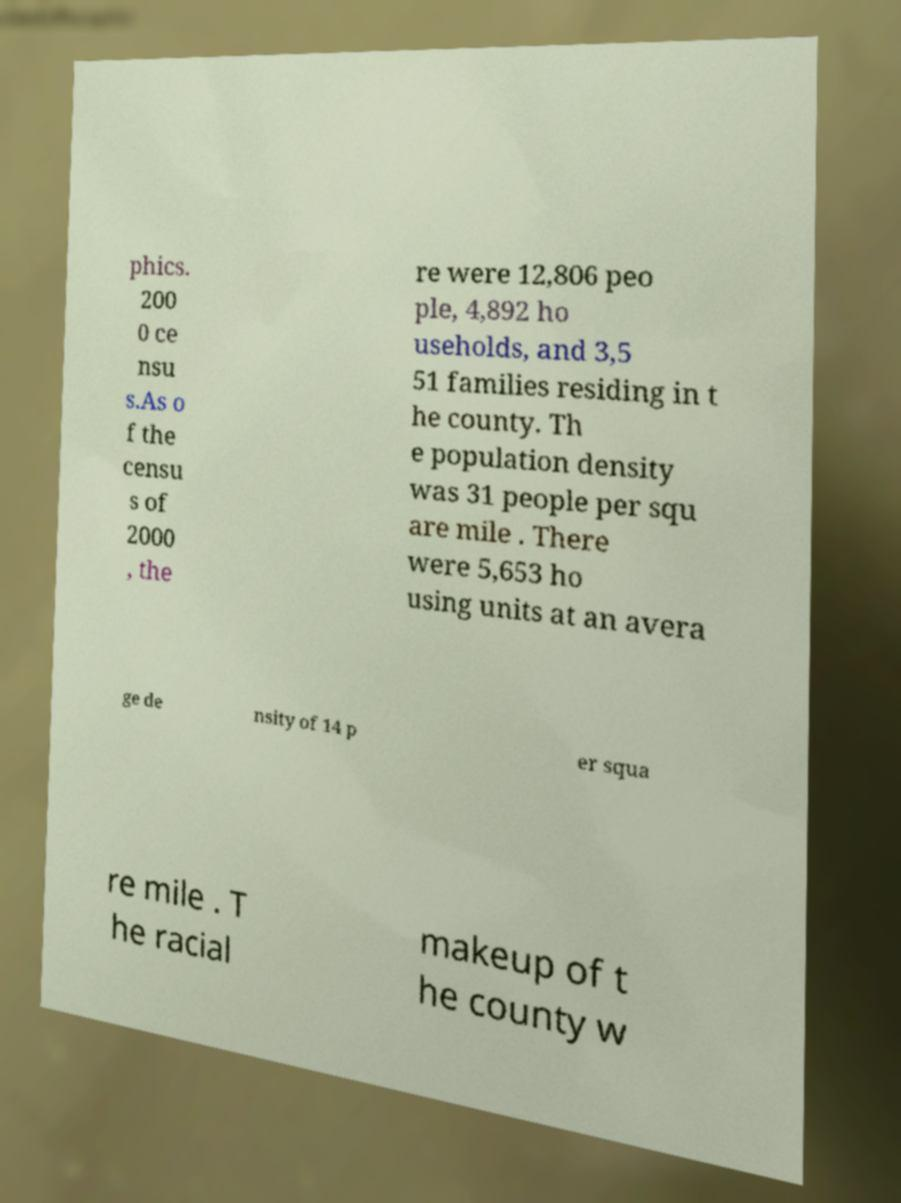For documentation purposes, I need the text within this image transcribed. Could you provide that? phics. 200 0 ce nsu s.As o f the censu s of 2000 , the re were 12,806 peo ple, 4,892 ho useholds, and 3,5 51 families residing in t he county. Th e population density was 31 people per squ are mile . There were 5,653 ho using units at an avera ge de nsity of 14 p er squa re mile . T he racial makeup of t he county w 